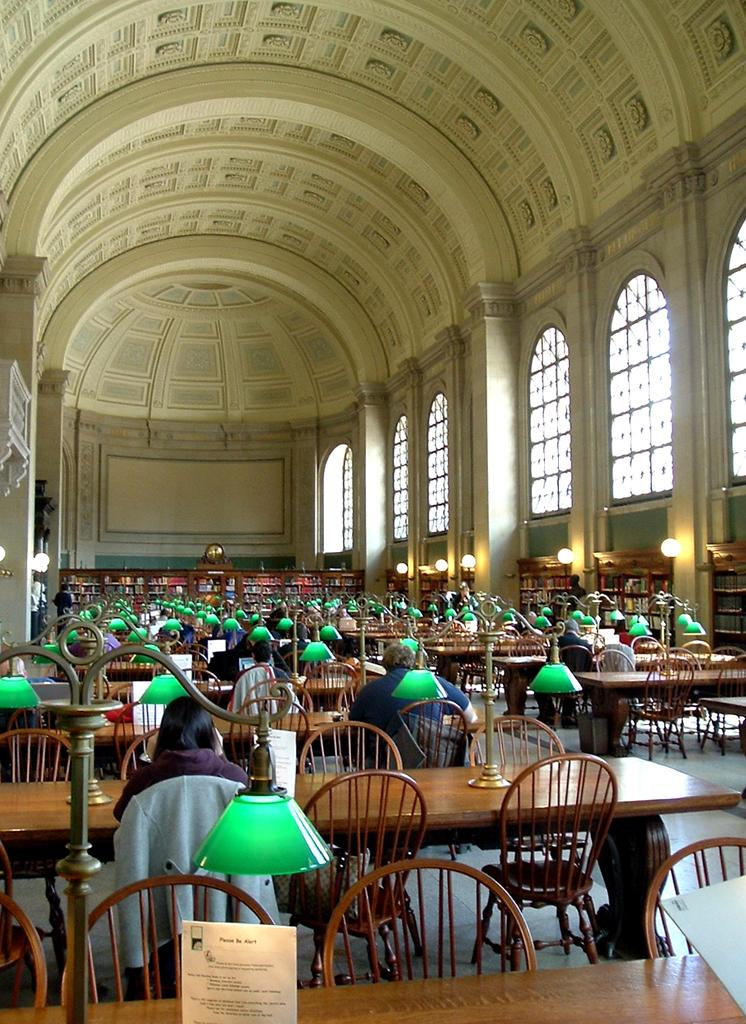How many people are in the image? There is a group of people in the image. What are the people doing in the image? The people are sitting on chairs. What is placed in front of the chairs? There are tables in front of the chairs. What can be seen on the tables? Lamp stands are present on the tables. What can be seen in the background of the image? There are windows visible in the background of the image. What type of amusement can be seen in the image? There is no amusement present in the image; it features a group of people sitting on chairs with tables and lamp stands. How many elbows are visible in the image? It is impossible to count elbows in the image, as the focus is on the group of people sitting on chairs and not on individual body parts. 